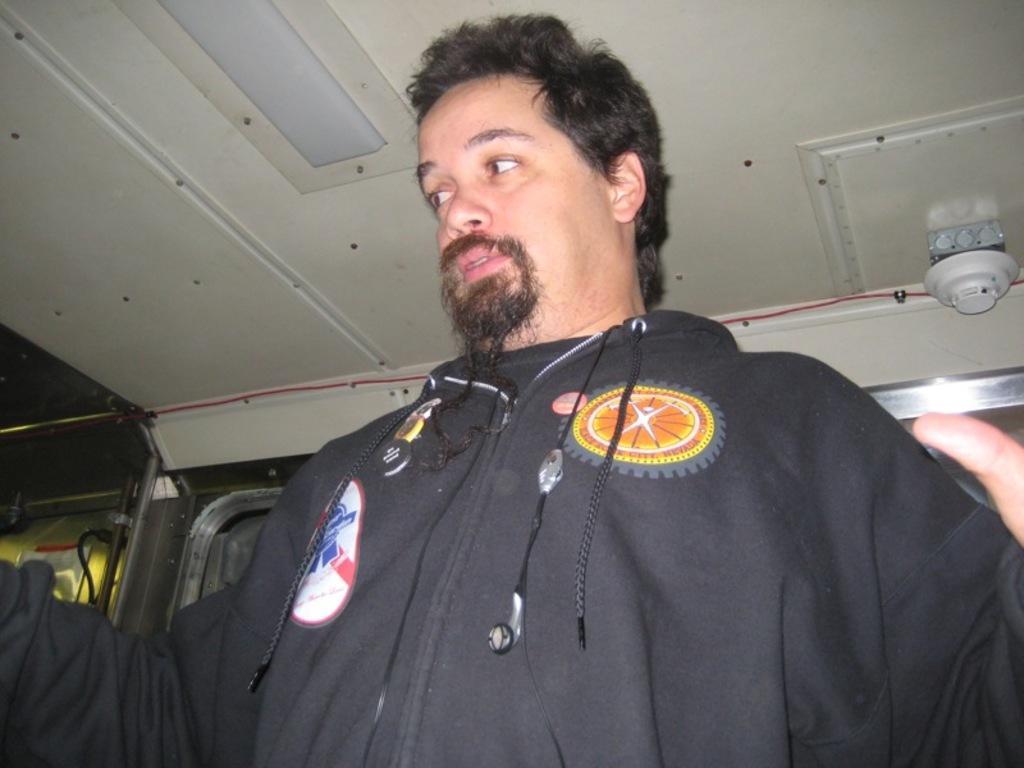Please provide a concise description of this image. In this image we can see a person looking opposite side and he wearing a black color dress. 